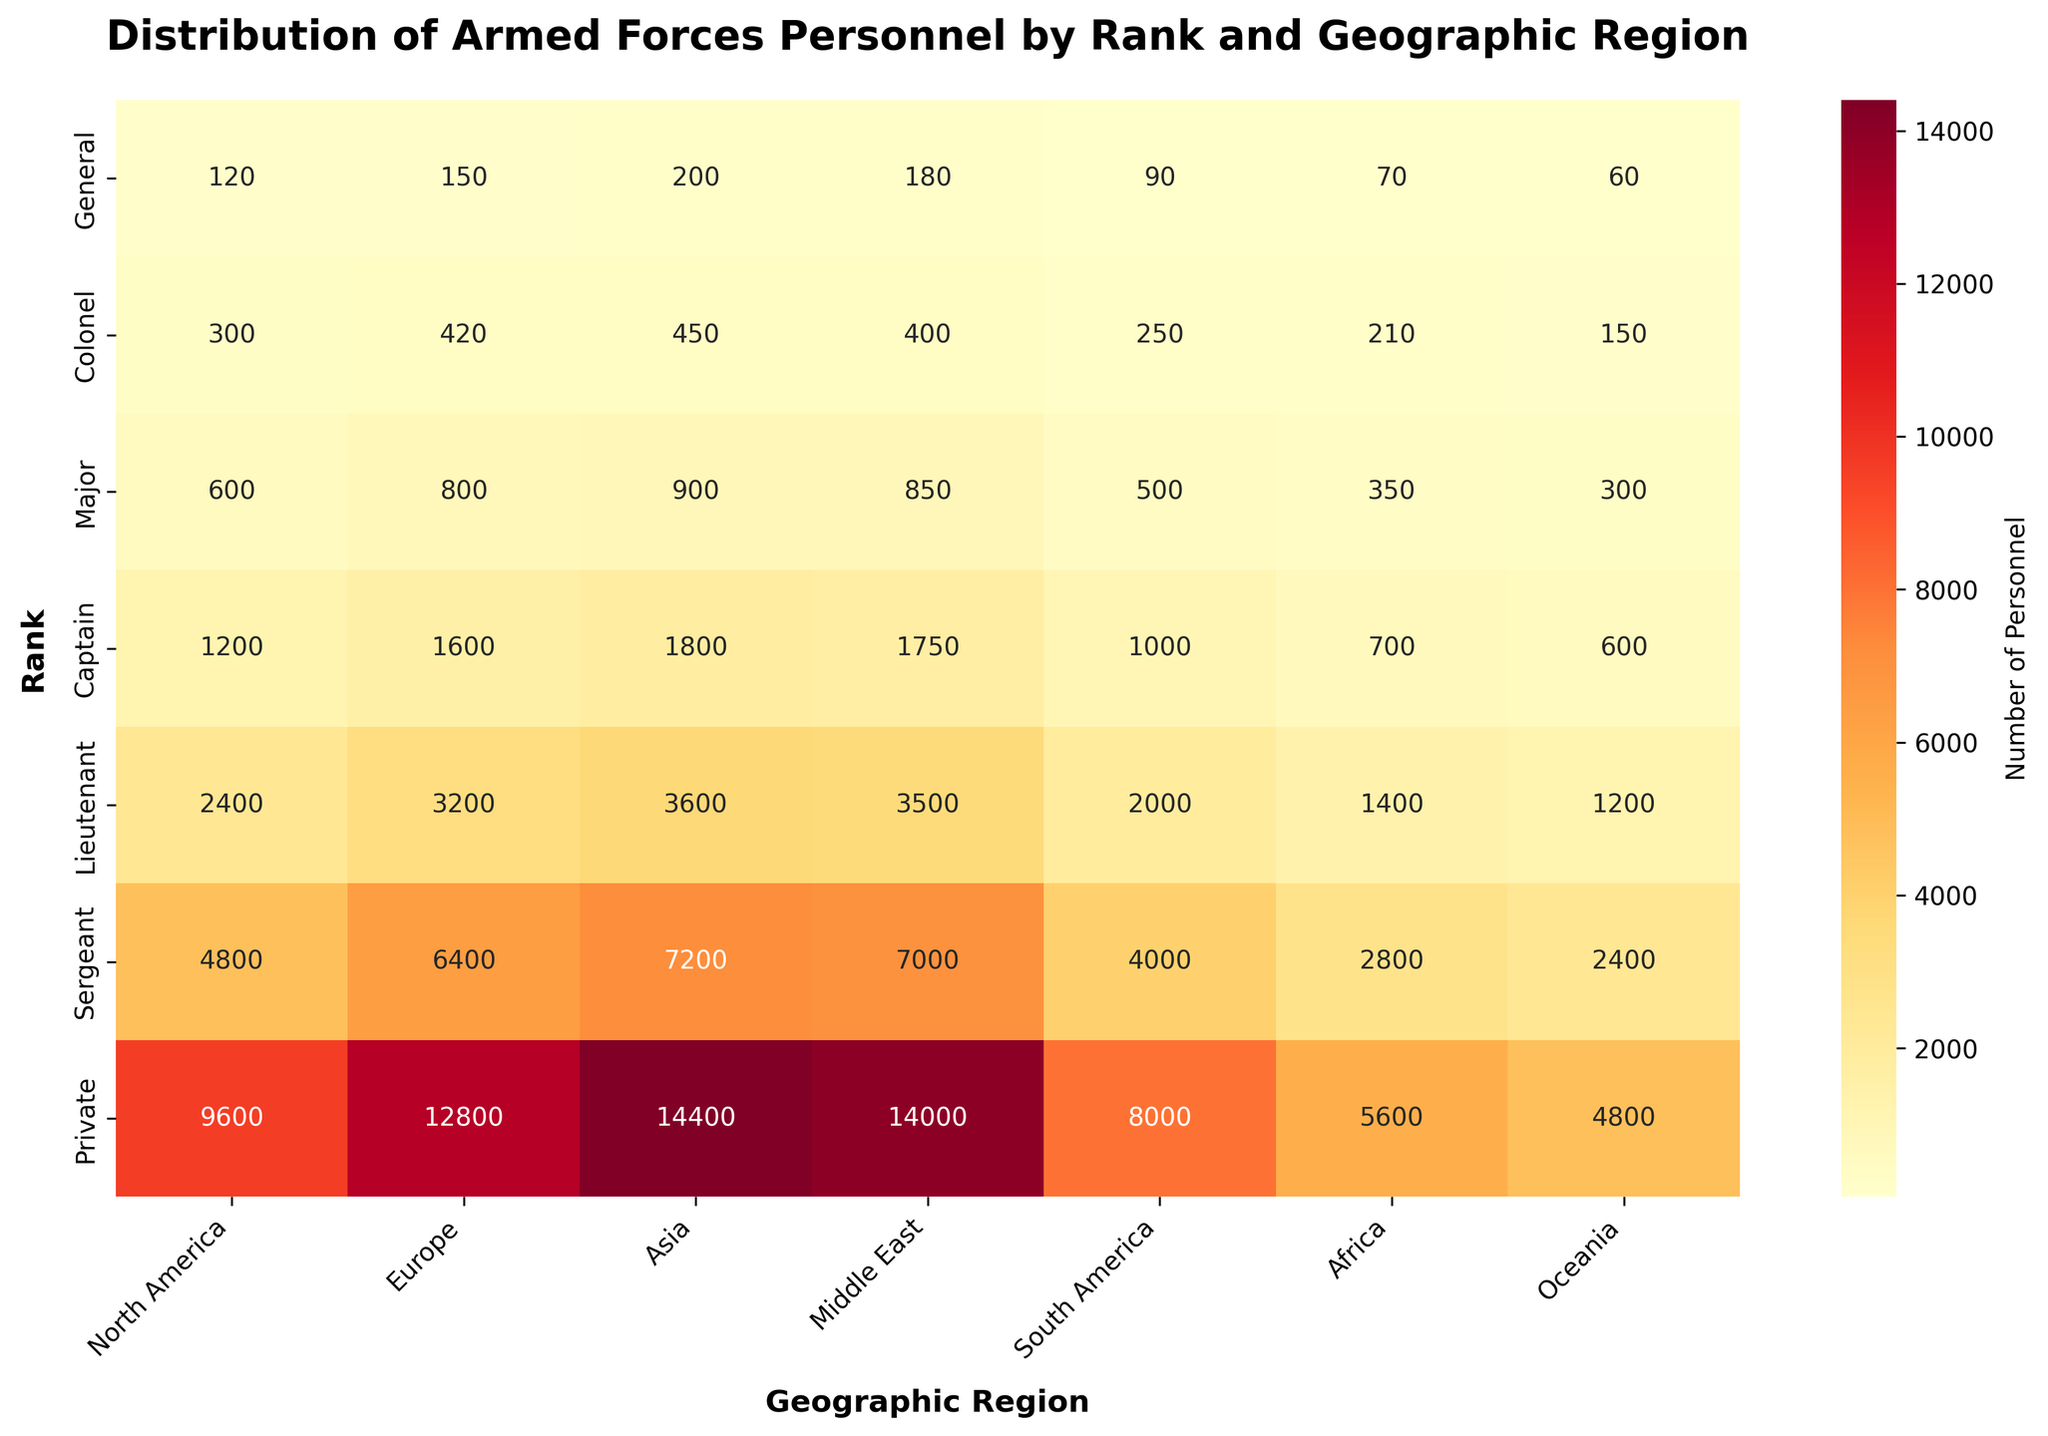What is the title of the figure? The title of the figure is typically found at the top of the plot, usually in a larger or bold font. It provides a brief description of what the plot represents. Here, the title is "Distribution of Armed Forces Personnel by Rank and Geographic Region."
Answer: Distribution of Armed Forces Personnel by Rank and Geographic Region How many regions are displayed on the heatmap? The regions are listed along the x-axis of the heatmap. By counting the labels, we find North America, Europe, Asia, Middle East, South America, Africa, and Oceania.
Answer: Seven Which region has the highest number of Generals? To find this information, look at the row labeled "General" and identify the highest value among the regions. The values are: North America (120), Europe (150), Asia (200), Middle East (180), South America (90), Africa (70), and Oceania (60).
Answer: Asia What is the difference in the number of Captains between Europe and North America? First, find the values for Captains in Europe and North America: Europe (1600) and North America (1200). The difference is calculated as 1600 - 1200.
Answer: 400 Which rank has the lowest personnel count in Africa? To determine this, identify the row with the lowest value in the Africa column. The values for Africa are: General (70), Colonel (210), Major (350), Captain (700), Lieutenant (1400), Sergeant (2800), Private (5600).
Answer: General How many total personnel are there in the Middle East for all ranks combined? Sum the values in the Middle East column: General (180), Colonel (400), Major (850), Captain (1750), Lieutenant (3500), Sergeant (7000), Private (14000). Total = 180 + 400 + 850 + 1750 + 3500 + 7000 + 14000.
Answer: 26,680 Are there more Colonels or Majors in South America? Compare the values for Colonels (250) and Majors (500) in the South America region. Majors have a higher count.
Answer: Majors Which region has the lowest number of personnel at the Private rank? Look at the row labeled "Private" and find the lowest value among the regions: North America (9600), Europe (12800), Asia (14400), Middle East (14000), South America (8000), Africa (5600), and Oceania (4800).
Answer: Oceania What is the average number of Lieutenants across all regions? Sum the values for Lieutenants across all regions: North America (2400), Europe (3200), Asia (3600), Middle East (3500), South America (2000), Africa (1400), and Oceania (1200). The total is 17300. Divide this by the number of regions (7) to find the average. Total = 17300 / 7.
Answer: 2471.43 (rounded) Which rank has the most evenly distributed personnel across all geographic regions? To find this, observe the heatmap row by row and look for the row where the personnel numbers are most similar across all regions. The Private rank has a consistent range of high values but similar distribution across regions.
Answer: Private 